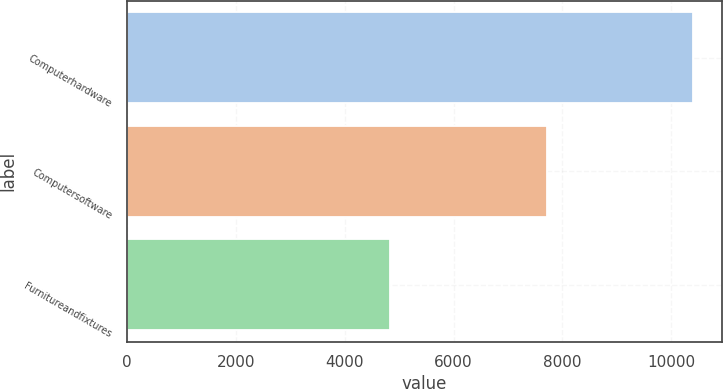<chart> <loc_0><loc_0><loc_500><loc_500><bar_chart><fcel>Computerhardware<fcel>Computersoftware<fcel>Furnitureandfixtures<nl><fcel>10404<fcel>7719<fcel>4835<nl></chart> 